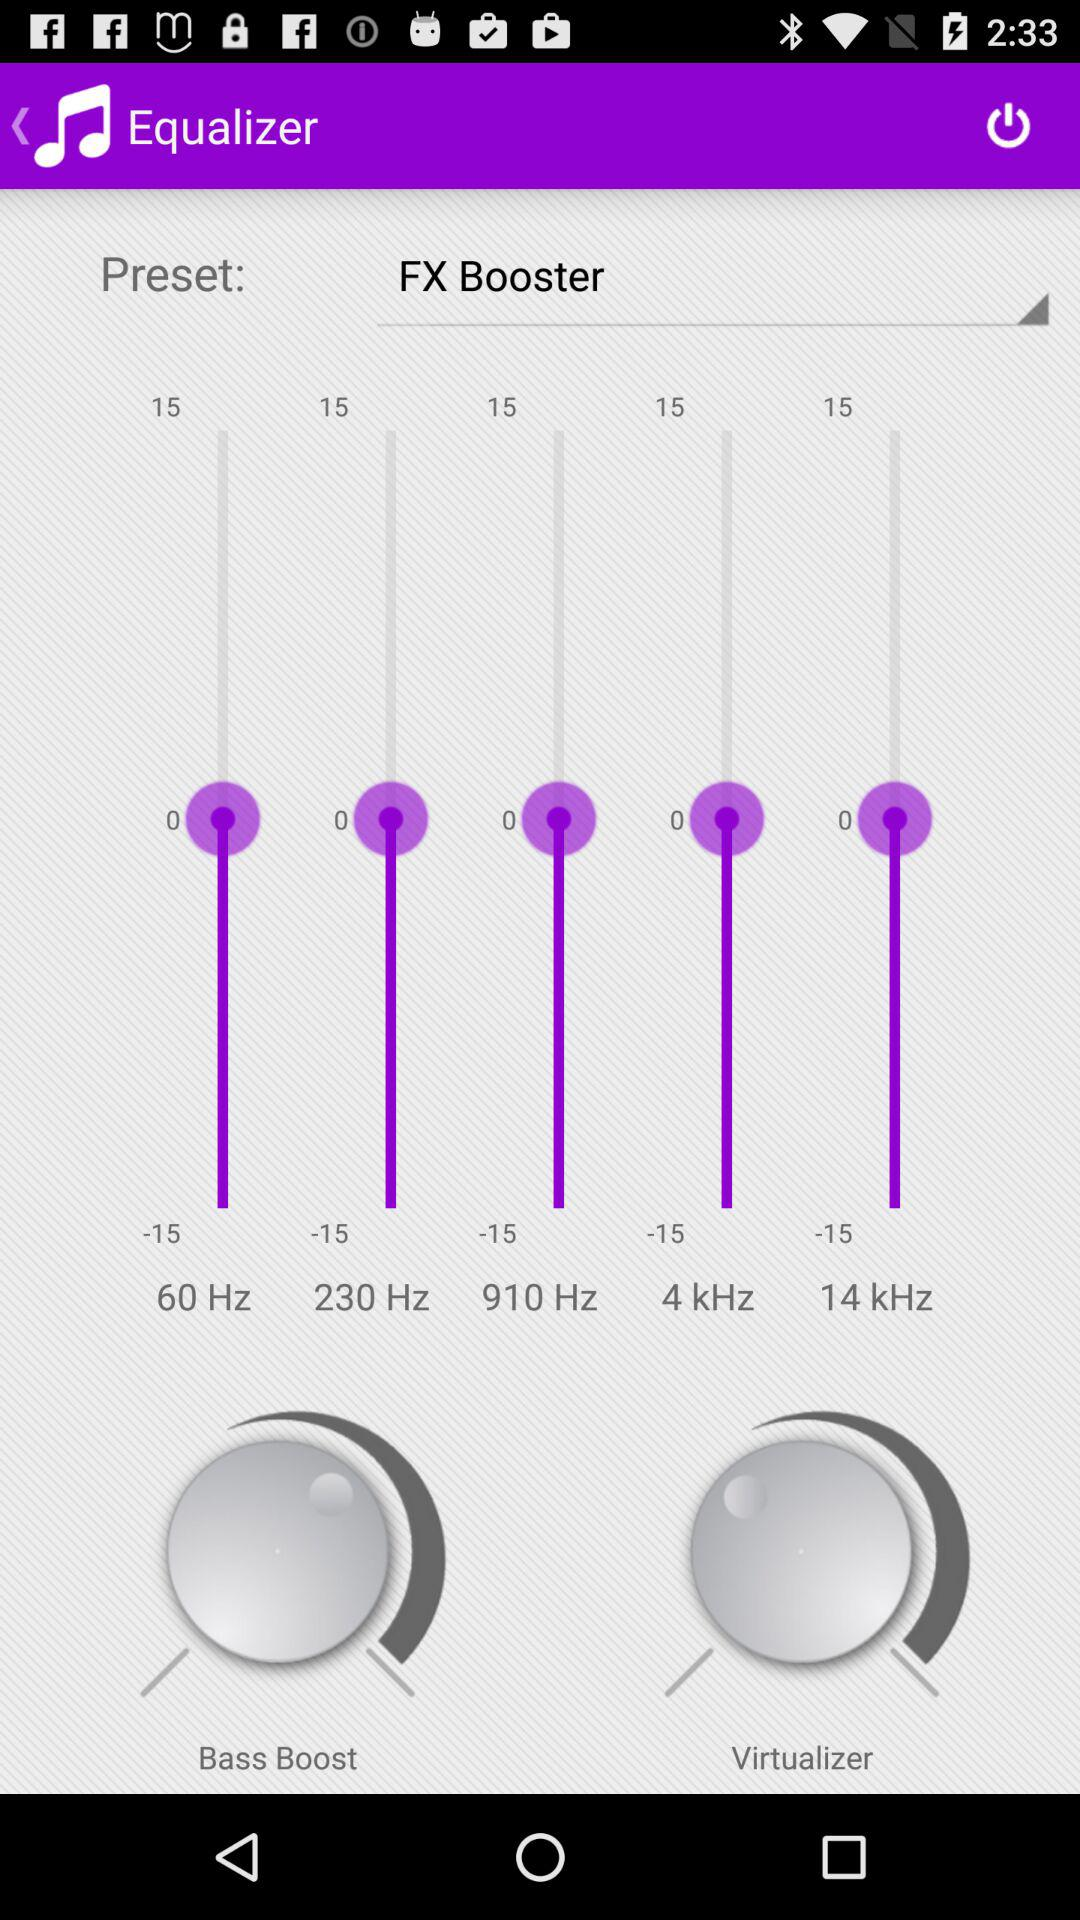What is the name of the application? The name of the application is "Equalizer". 